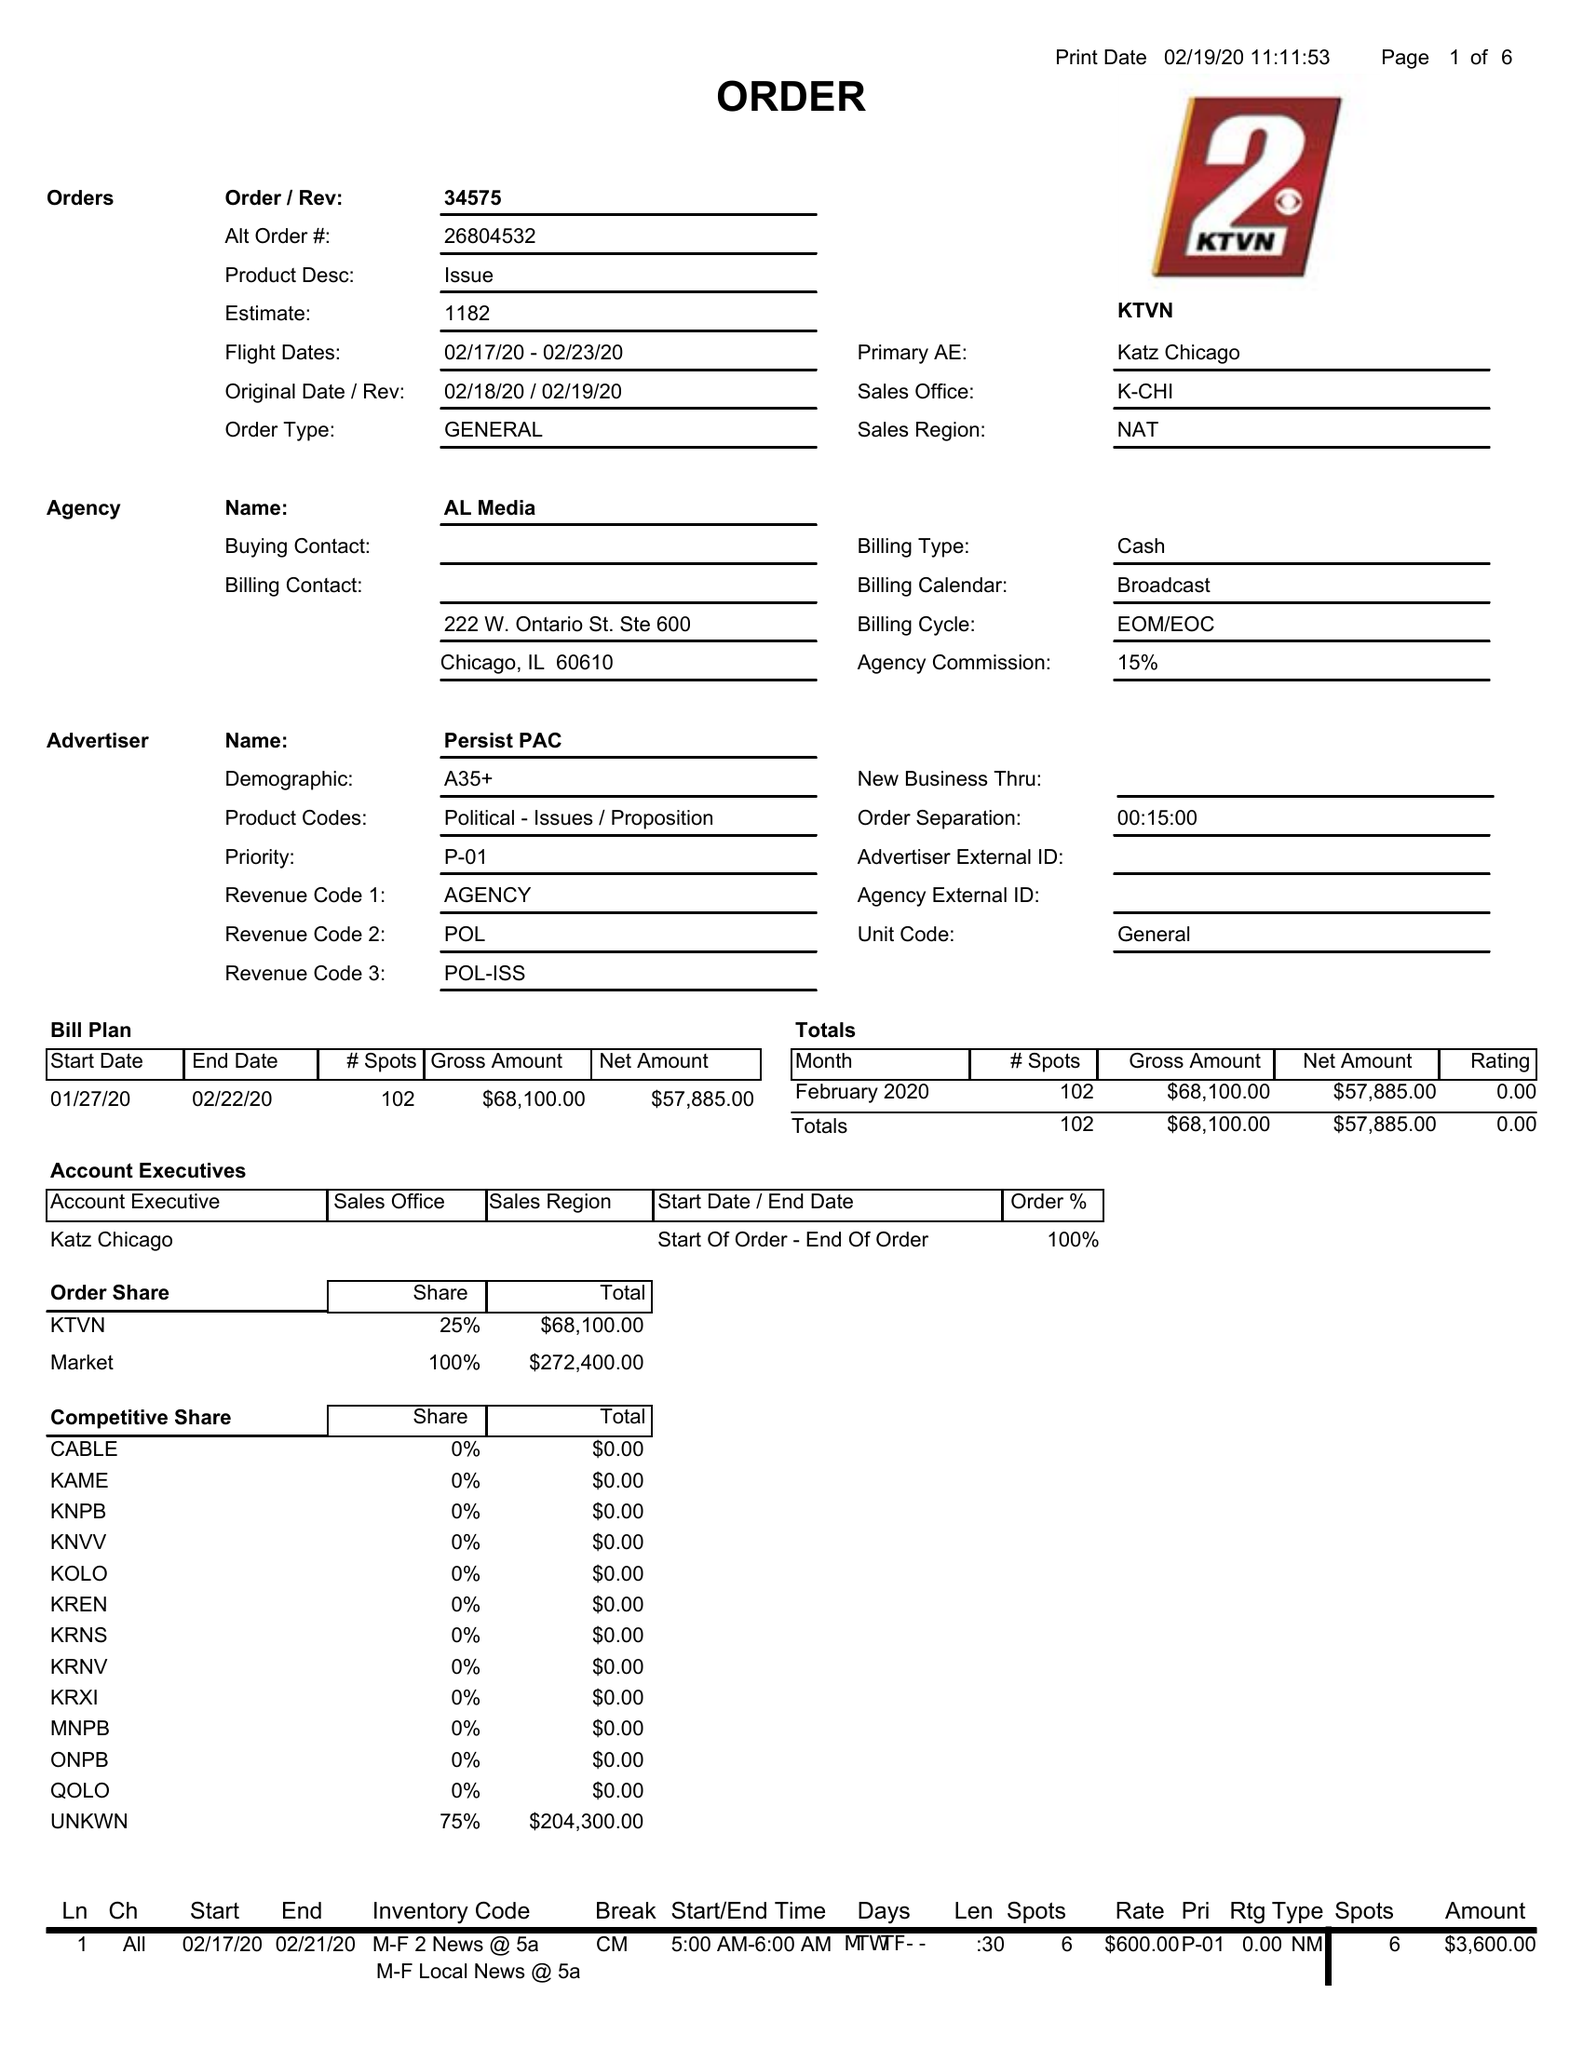What is the value for the contract_num?
Answer the question using a single word or phrase. 34575 